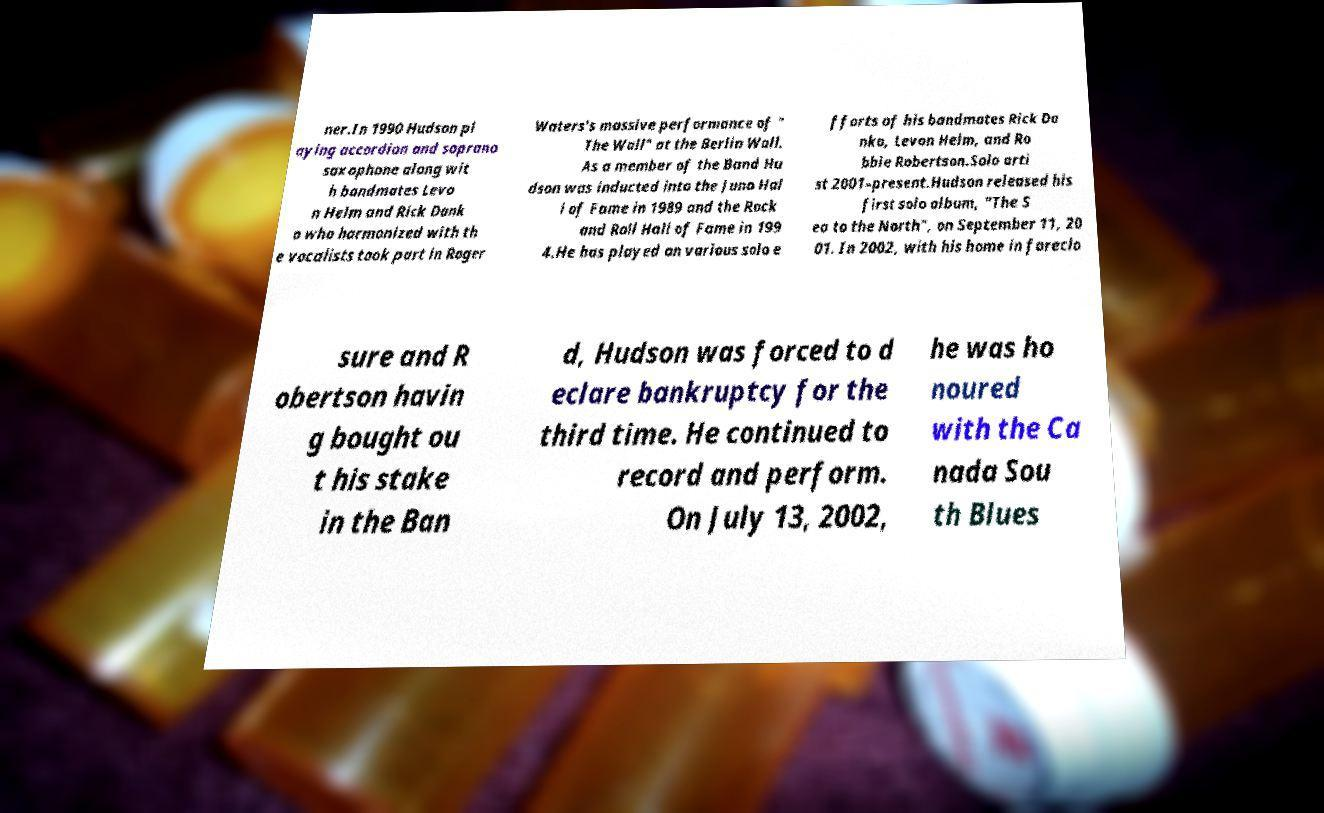Could you extract and type out the text from this image? ner.In 1990 Hudson pl aying accordion and soprano saxophone along wit h bandmates Levo n Helm and Rick Dank o who harmonized with th e vocalists took part in Roger Waters's massive performance of " The Wall" at the Berlin Wall. As a member of the Band Hu dson was inducted into the Juno Hal l of Fame in 1989 and the Rock and Roll Hall of Fame in 199 4.He has played on various solo e fforts of his bandmates Rick Da nko, Levon Helm, and Ro bbie Robertson.Solo arti st 2001–present.Hudson released his first solo album, "The S ea to the North", on September 11, 20 01. In 2002, with his home in foreclo sure and R obertson havin g bought ou t his stake in the Ban d, Hudson was forced to d eclare bankruptcy for the third time. He continued to record and perform. On July 13, 2002, he was ho noured with the Ca nada Sou th Blues 